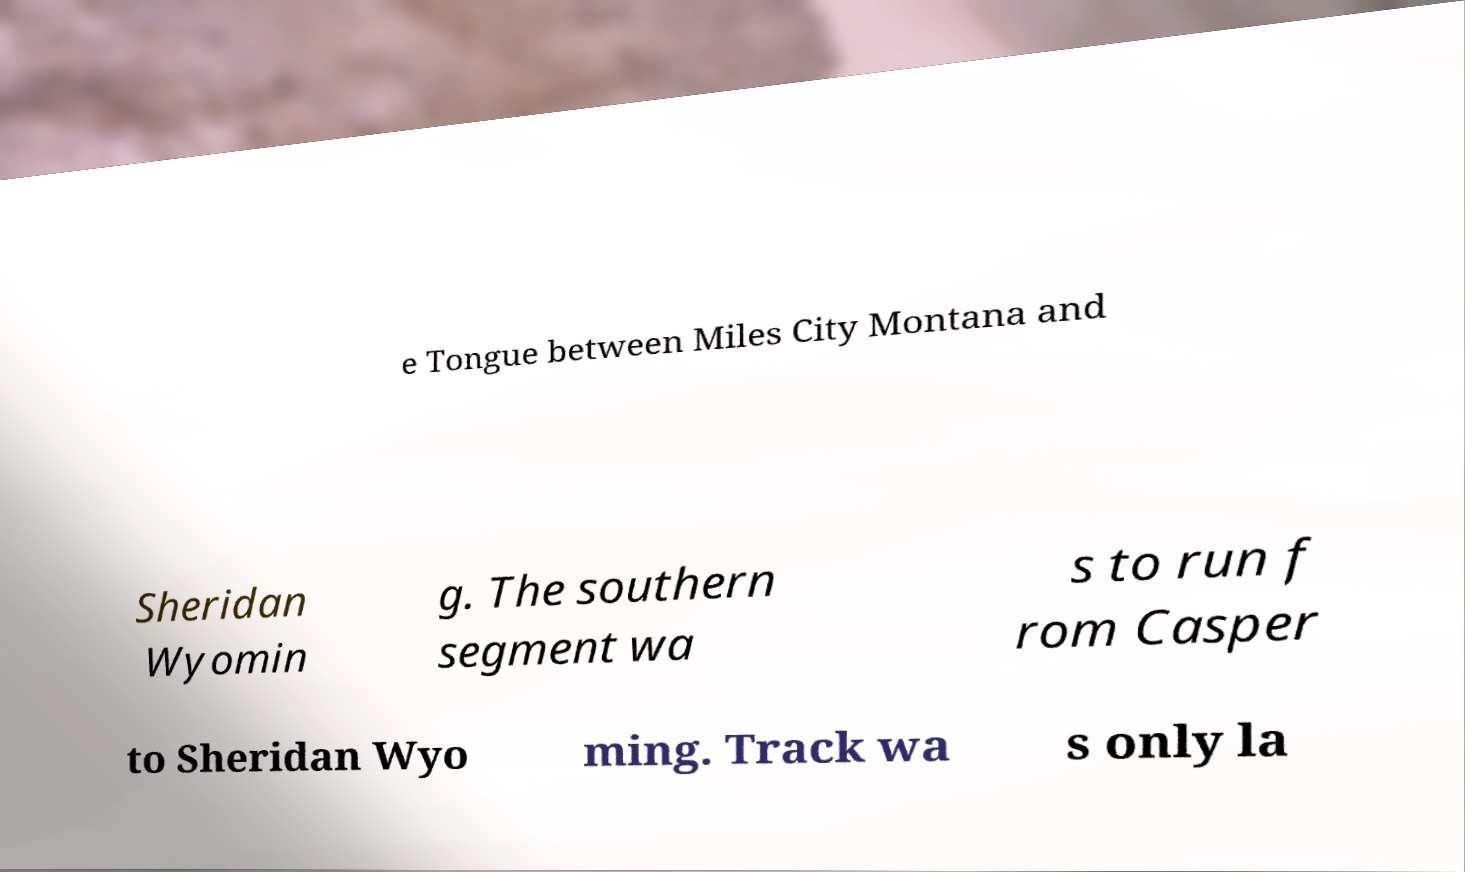What messages or text are displayed in this image? I need them in a readable, typed format. e Tongue between Miles City Montana and Sheridan Wyomin g. The southern segment wa s to run f rom Casper to Sheridan Wyo ming. Track wa s only la 